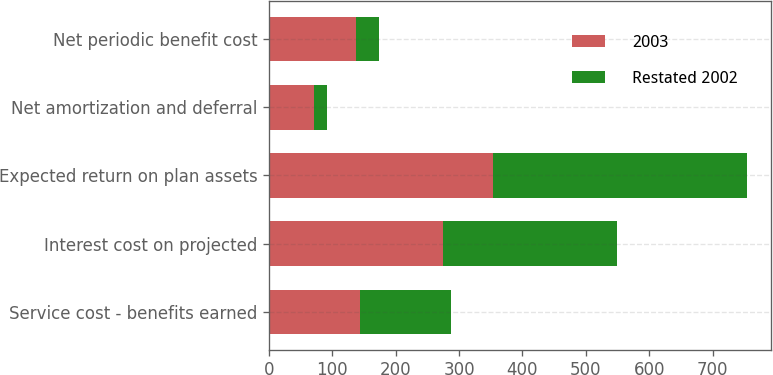<chart> <loc_0><loc_0><loc_500><loc_500><stacked_bar_chart><ecel><fcel>Service cost - benefits earned<fcel>Interest cost on projected<fcel>Expected return on plan assets<fcel>Net amortization and deferral<fcel>Net periodic benefit cost<nl><fcel>2003<fcel>144<fcel>275<fcel>353<fcel>71<fcel>137<nl><fcel>Restated 2002<fcel>143<fcel>275<fcel>402<fcel>21<fcel>37<nl></chart> 